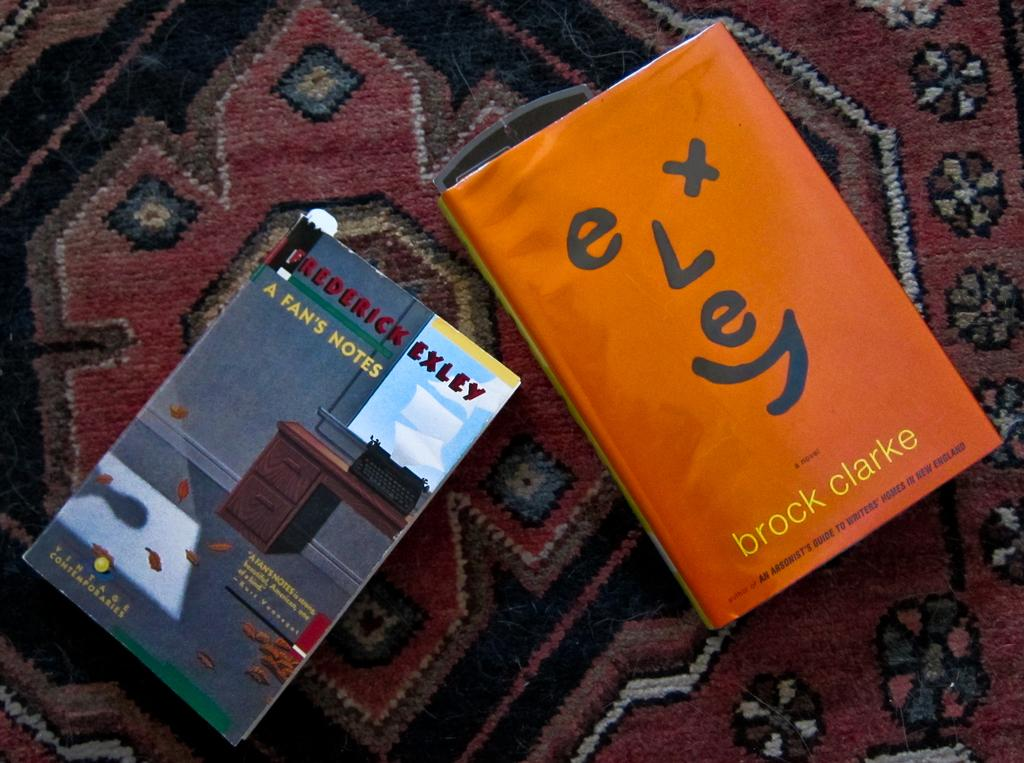<image>
Relay a brief, clear account of the picture shown. Orange book by Brock Clarke next to another book. 